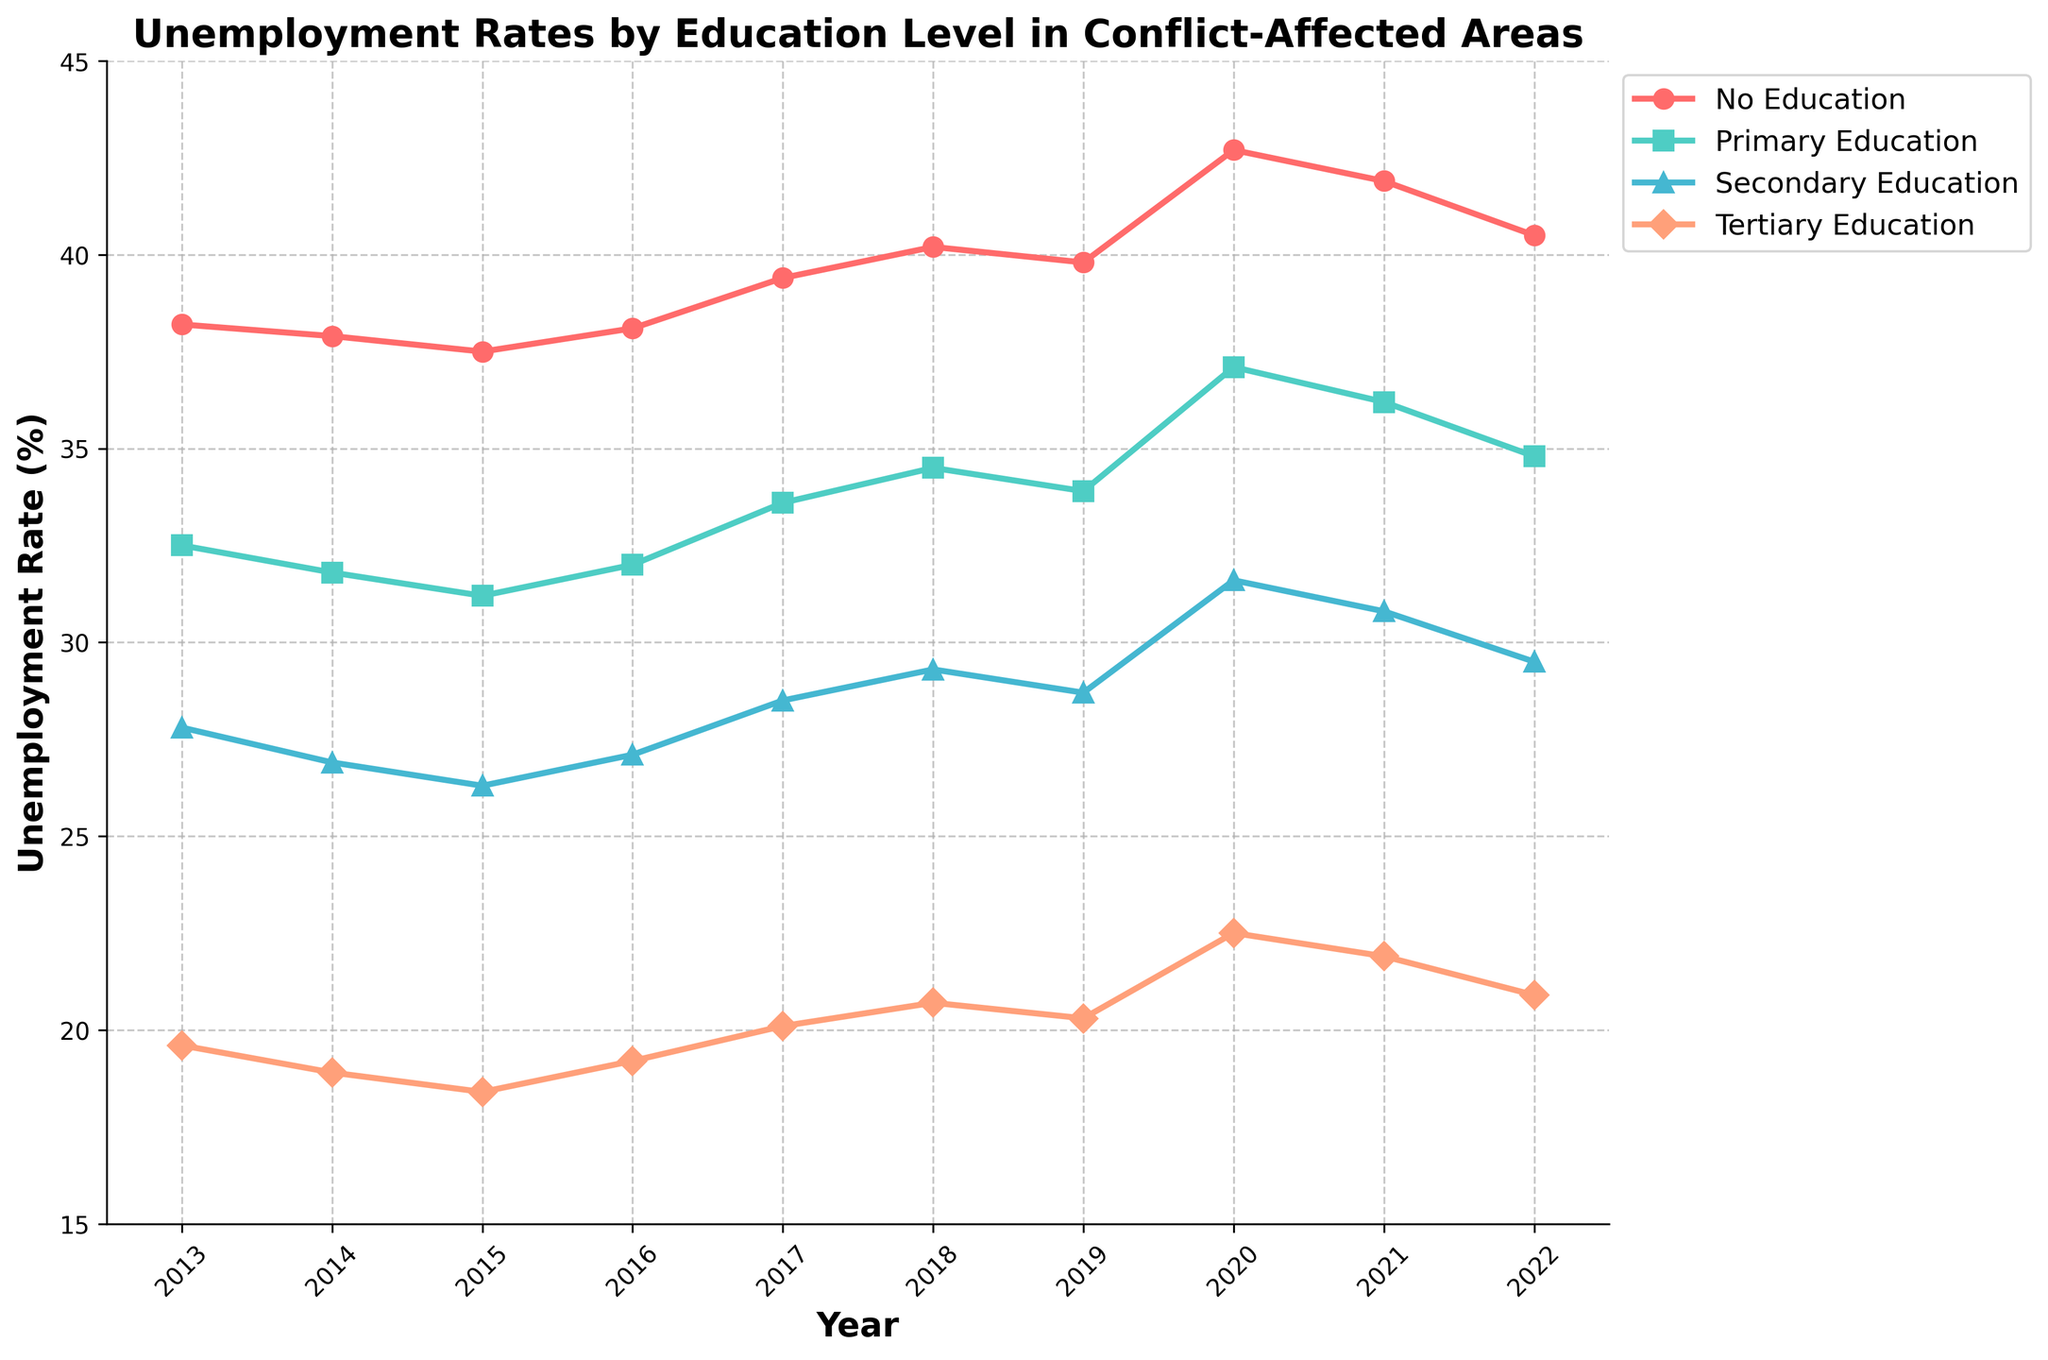Which education level has the highest unemployment rate in 2020? Look at the markers for the year 2020. The red marker ('No Education') is the highest at around 42.7%.
Answer: No Education How did the unemployment rate for those with secondary education change from 2015 to 2017? Find the blue markers for the years 2015 and 2017. The values change from 26.3% in 2015 to 28.5% in 2017.
Answer: It increased What's the average unemployment rate for primary education over the whole period? Add the unemployment rates for 'Primary Education' for all years: (32.5 + 31.8 + 31.2 + 32.0 + 33.6 + 34.5 + 33.9 + 37.1 + 36.2 + 34.8). Divide the sum by the number of years (10). (328.6 / 10 = 32.86)
Answer: 32.86% In which year was the unemployment rate for tertiary education the lowest? Look at the orange markers for 'Tertiary Education' across all years. The lowest is in 2015 at 18.4%.
Answer: 2015 By how much did the unemployment rate for no education increase from 2019 to 2020? Find the red markers for the years 2019 and 2020. The rate increased from 39.8% to 42.7%. (42.7 - 39.8 = 2.9)
Answer: 2.9% How does the unemployment rate in 2022 for tertiary education compare to that in 2021? Compare the values for 'Tertiary Education' in 2022 (20.9%) and 2021 (21.9%).
Answer: It decreased What is the general trend in unemployment rates for people with no education over the decade? Look at the red line representing 'No Education'. The general trend is an increase starting from 2013 to 2020, followed by a slight decrease by 2022.
Answer: Generally increasing Which education level had the smallest change in unemployment rates between 2013 and 2022? Compare the differences between 2013 and 2022 for all education levels: No Education (2.3), Primary (2.3), Secondary (1.7), Tertiary (1.3). Tertiary has the smallest change.
Answer: Tertiary Education Between 2017 and 2019, which education level saw a decrease in unemployment rates? Compare the markers for each education level between 2017 and 2019. Both 'No Education' and 'Secondary Education' saw a decrease.
Answer: No Education, Secondary Education What was the approximate unemployment rate for primary education in 2018? Find the green marker for 'Primary Education' in the year 2018, which is around 34.5%.
Answer: 34.5% 